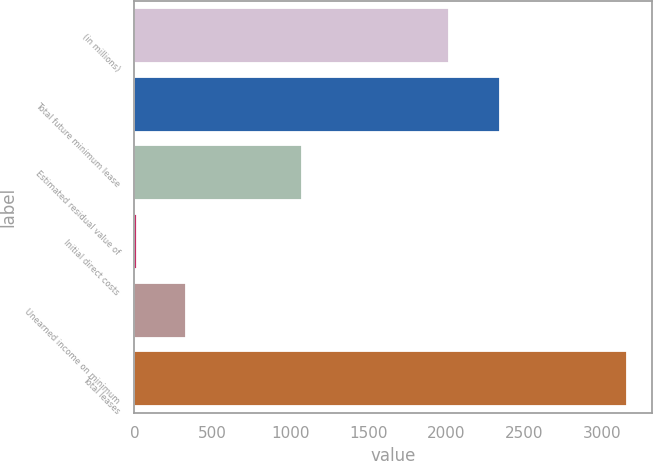<chart> <loc_0><loc_0><loc_500><loc_500><bar_chart><fcel>(in millions)<fcel>Total future minimum lease<fcel>Estimated residual value of<fcel>Initial direct costs<fcel>Unearned income on minimum<fcel>Total leases<nl><fcel>2017<fcel>2347<fcel>1072<fcel>15<fcel>329.6<fcel>3161<nl></chart> 